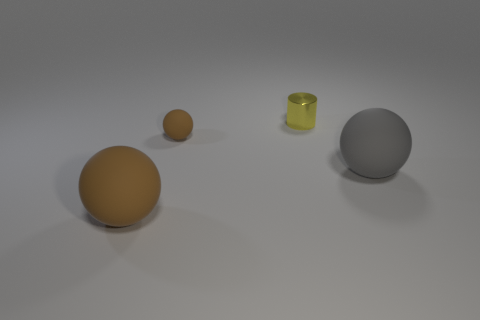Add 2 big balls. How many objects exist? 6 Subtract all cylinders. How many objects are left? 3 Subtract all balls. Subtract all small yellow metallic objects. How many objects are left? 0 Add 2 brown matte objects. How many brown matte objects are left? 4 Add 2 large brown spheres. How many large brown spheres exist? 3 Subtract 0 cyan cylinders. How many objects are left? 4 